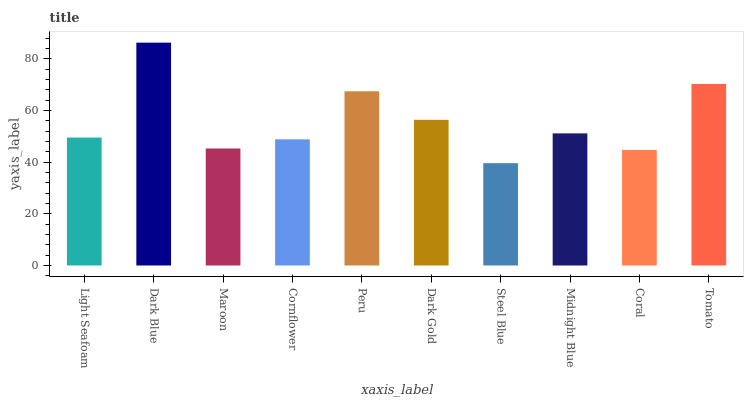Is Steel Blue the minimum?
Answer yes or no. Yes. Is Dark Blue the maximum?
Answer yes or no. Yes. Is Maroon the minimum?
Answer yes or no. No. Is Maroon the maximum?
Answer yes or no. No. Is Dark Blue greater than Maroon?
Answer yes or no. Yes. Is Maroon less than Dark Blue?
Answer yes or no. Yes. Is Maroon greater than Dark Blue?
Answer yes or no. No. Is Dark Blue less than Maroon?
Answer yes or no. No. Is Midnight Blue the high median?
Answer yes or no. Yes. Is Light Seafoam the low median?
Answer yes or no. Yes. Is Coral the high median?
Answer yes or no. No. Is Dark Blue the low median?
Answer yes or no. No. 